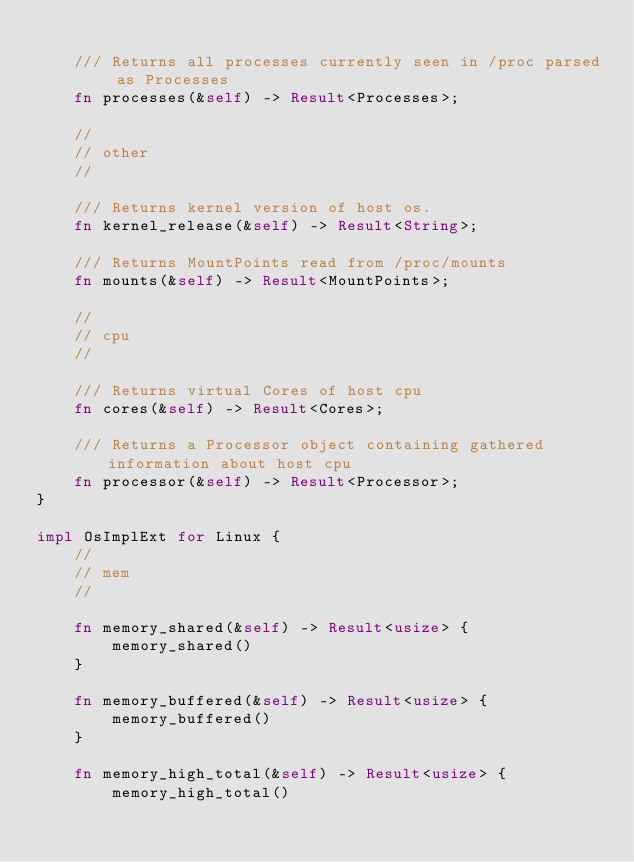Convert code to text. <code><loc_0><loc_0><loc_500><loc_500><_Rust_>
    /// Returns all processes currently seen in /proc parsed as Processes
    fn processes(&self) -> Result<Processes>;

    //
    // other
    //

    /// Returns kernel version of host os.
    fn kernel_release(&self) -> Result<String>;

    /// Returns MountPoints read from /proc/mounts
    fn mounts(&self) -> Result<MountPoints>;

    //
    // cpu
    //

    /// Returns virtual Cores of host cpu
    fn cores(&self) -> Result<Cores>;

    /// Returns a Processor object containing gathered information about host cpu
    fn processor(&self) -> Result<Processor>;
}

impl OsImplExt for Linux {
    //
    // mem
    //

    fn memory_shared(&self) -> Result<usize> {
        memory_shared()
    }

    fn memory_buffered(&self) -> Result<usize> {
        memory_buffered()
    }

    fn memory_high_total(&self) -> Result<usize> {
        memory_high_total()</code> 